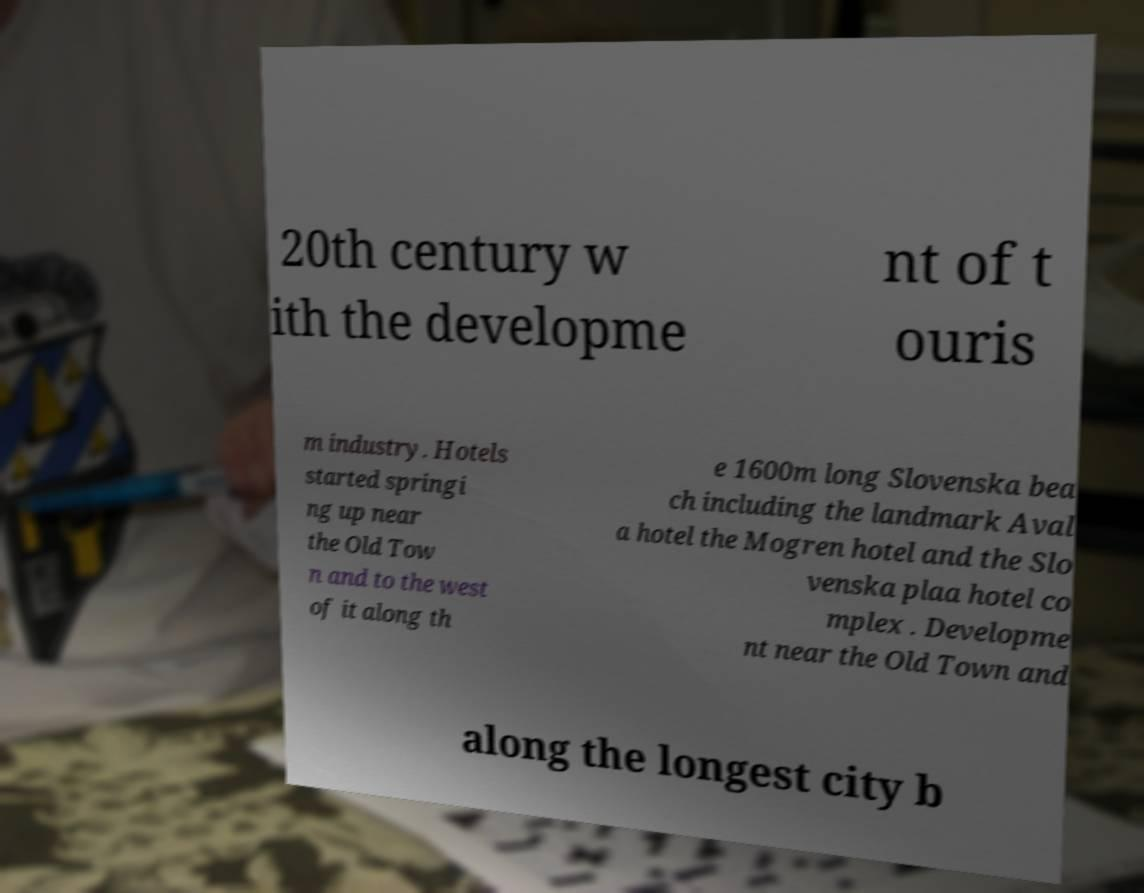Could you assist in decoding the text presented in this image and type it out clearly? 20th century w ith the developme nt of t ouris m industry. Hotels started springi ng up near the Old Tow n and to the west of it along th e 1600m long Slovenska bea ch including the landmark Aval a hotel the Mogren hotel and the Slo venska plaa hotel co mplex . Developme nt near the Old Town and along the longest city b 